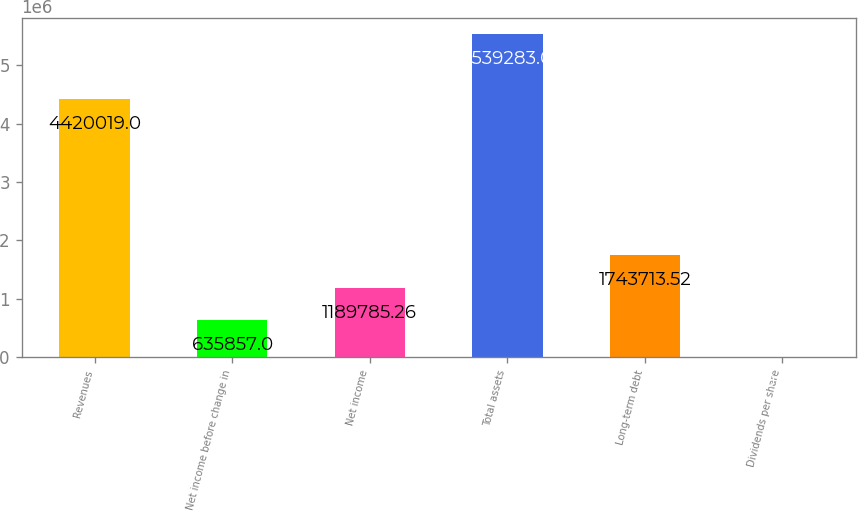<chart> <loc_0><loc_0><loc_500><loc_500><bar_chart><fcel>Revenues<fcel>Net income before change in<fcel>Net income<fcel>Total assets<fcel>Long-term debt<fcel>Dividends per share<nl><fcel>4.42002e+06<fcel>635857<fcel>1.18979e+06<fcel>5.53928e+06<fcel>1.74371e+06<fcel>0.43<nl></chart> 